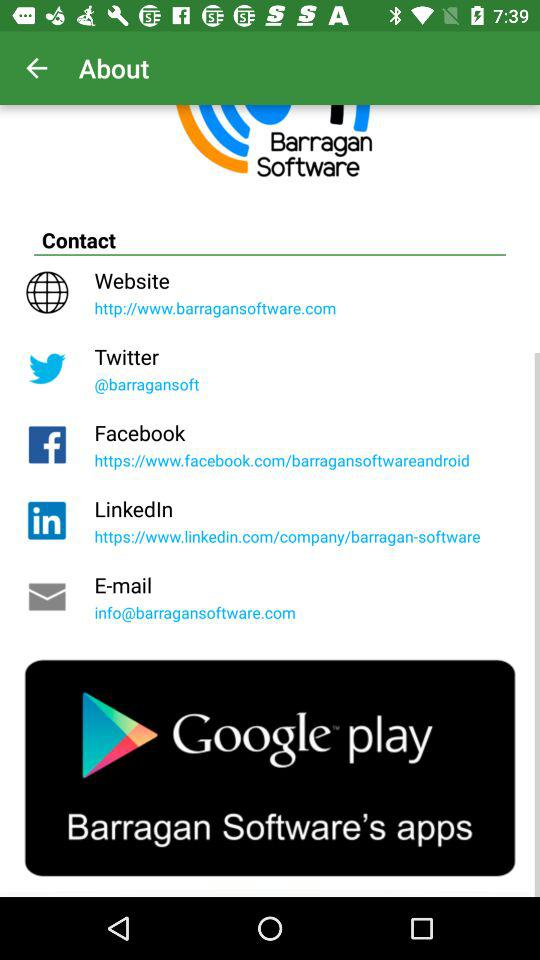What is the email address of the company? The email address is info@barragansoftware.com. 